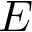Convert formula to latex. <formula><loc_0><loc_0><loc_500><loc_500>E</formula> 